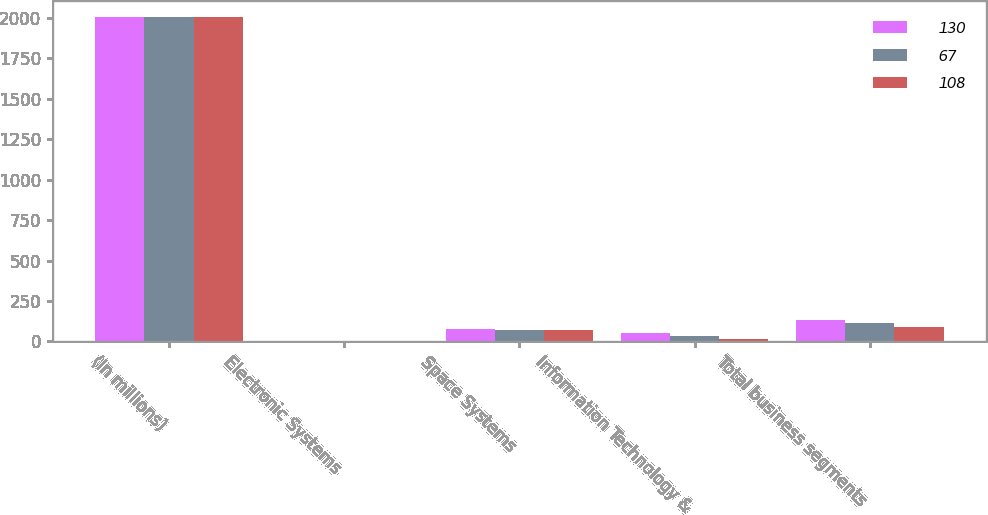<chart> <loc_0><loc_0><loc_500><loc_500><stacked_bar_chart><ecel><fcel>(In millions)<fcel>Electronic Systems<fcel>Space Systems<fcel>Information Technology &<fcel>Total business segments<nl><fcel>130<fcel>2006<fcel>3<fcel>78<fcel>49<fcel>130<nl><fcel>67<fcel>2005<fcel>4<fcel>72<fcel>35<fcel>111<nl><fcel>108<fcel>2004<fcel>5<fcel>71<fcel>16<fcel>92<nl></chart> 